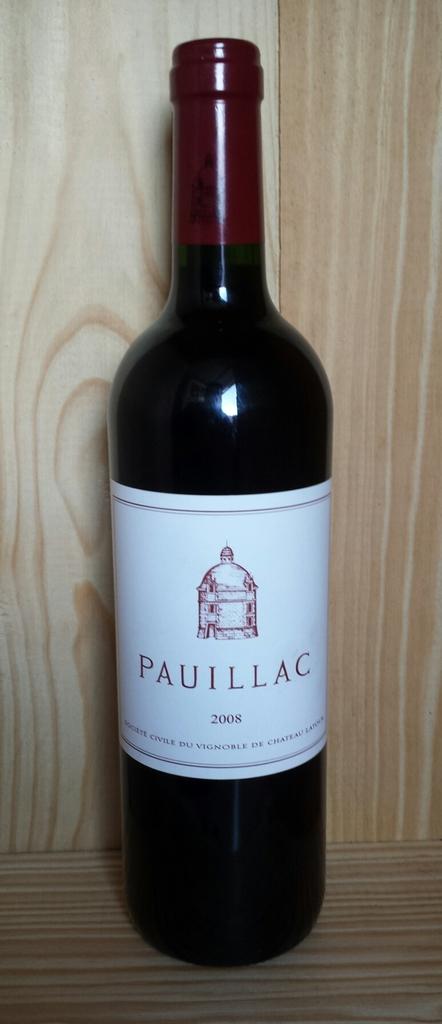What is the name of the wine pictured?
Make the answer very short. Pauillac. What year is on the wine bottle?
Keep it short and to the point. 2008. 